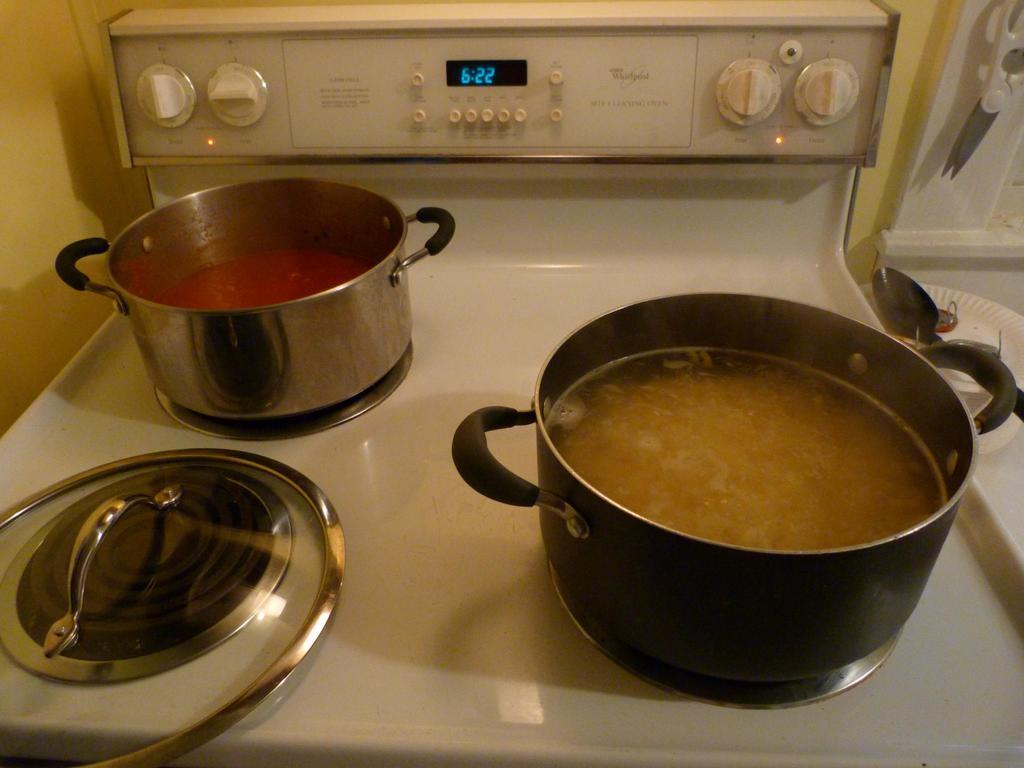<image>
Present a compact description of the photo's key features. Two pots of food cooking on a stove which shows the time as 6:22. 